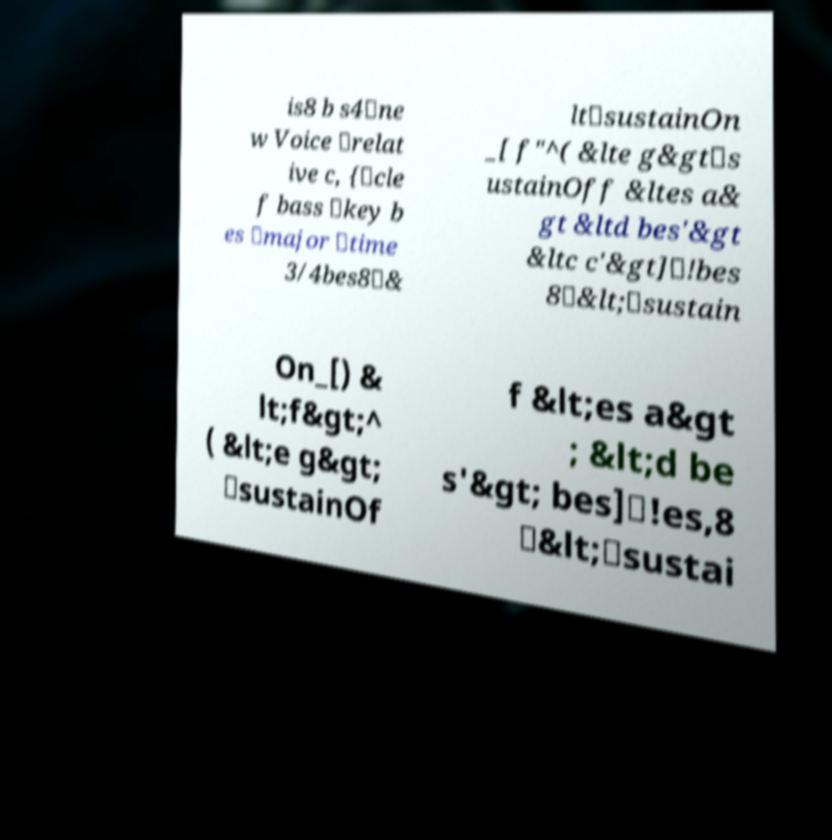Could you assist in decoding the text presented in this image and type it out clearly? is8 b s4\ne w Voice \relat ive c, {\cle f bass \key b es \major \time 3/4bes8\& lt\sustainOn _[ f"^( &lte g&gt\s ustainOff &ltes a& gt &ltd bes'&gt &ltc c'&gt]\!bes 8\&lt;\sustain On_[) & lt;f&gt;^ ( &lt;e g&gt; \sustainOf f &lt;es a&gt ; &lt;d be s'&gt; bes]\!es,8 \&lt;\sustai 